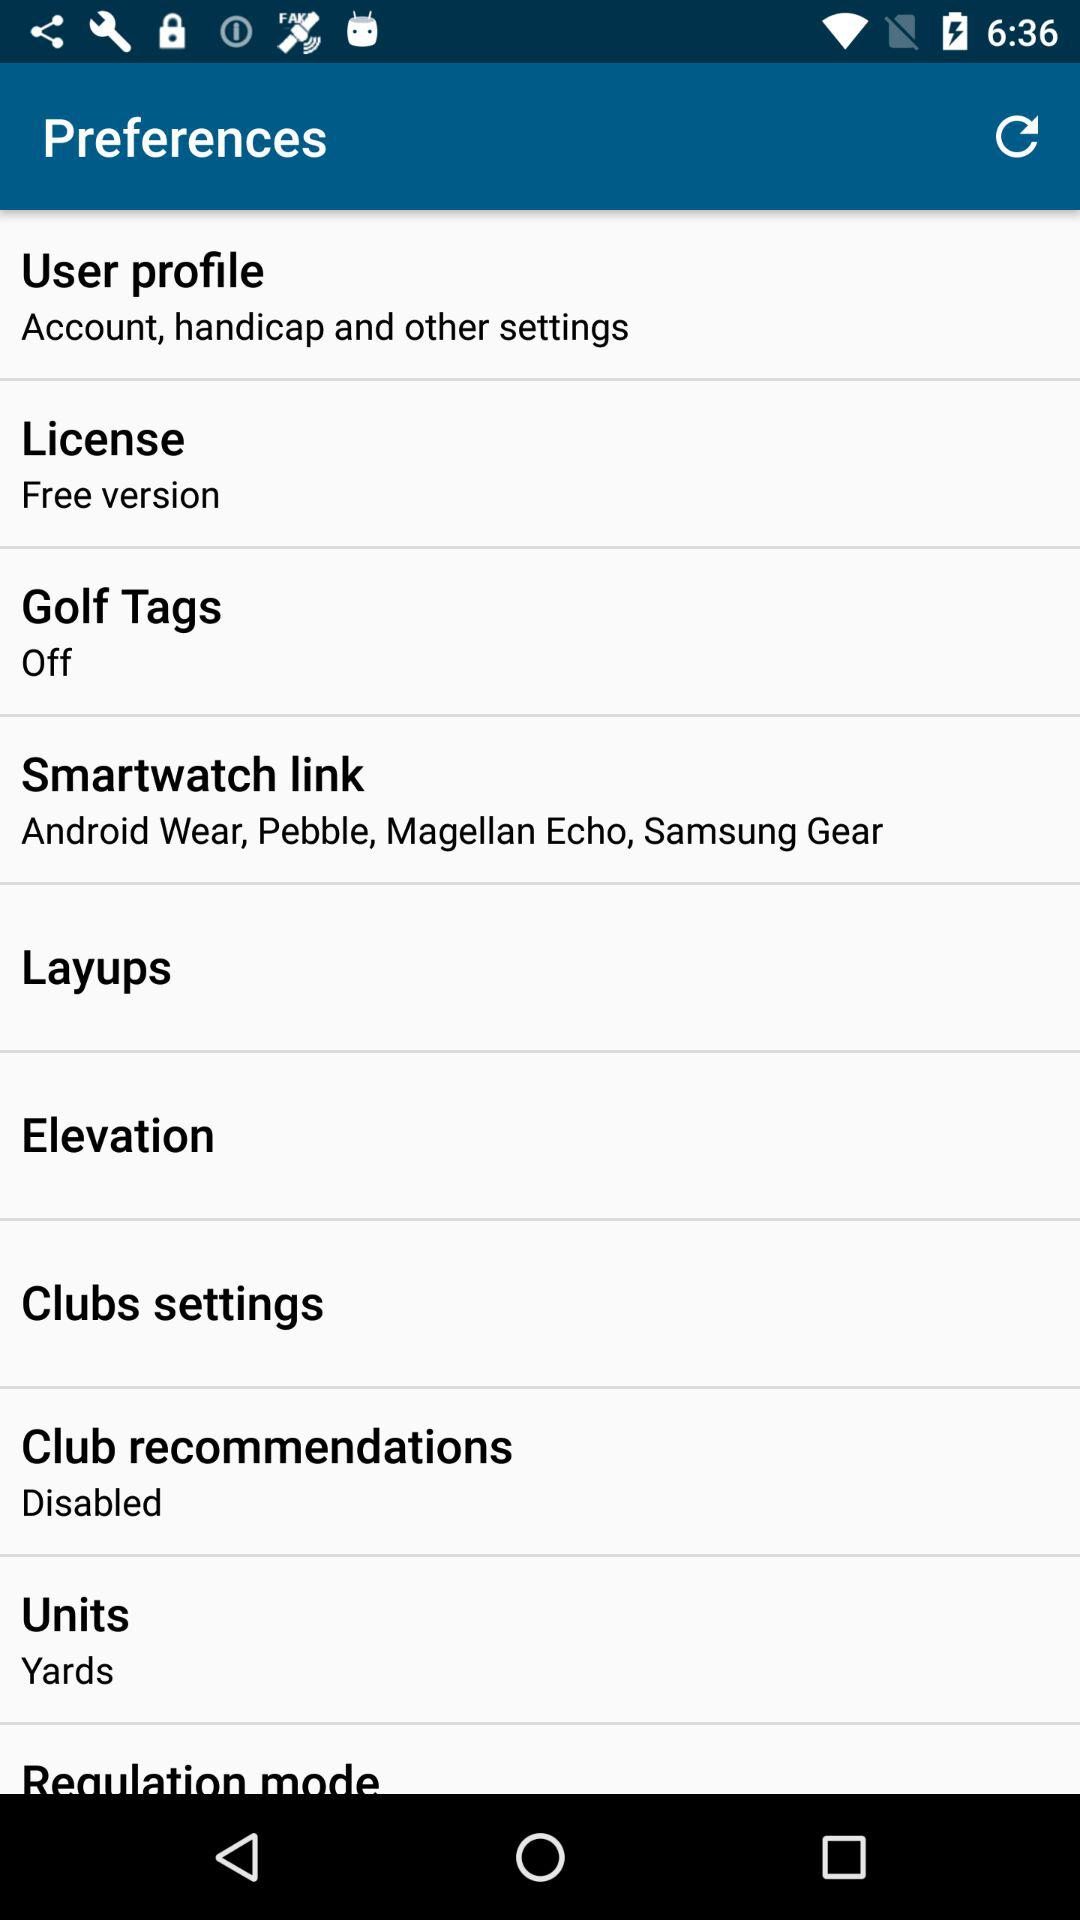What is the option selected in Units? The selected option in Units is "Yards". 